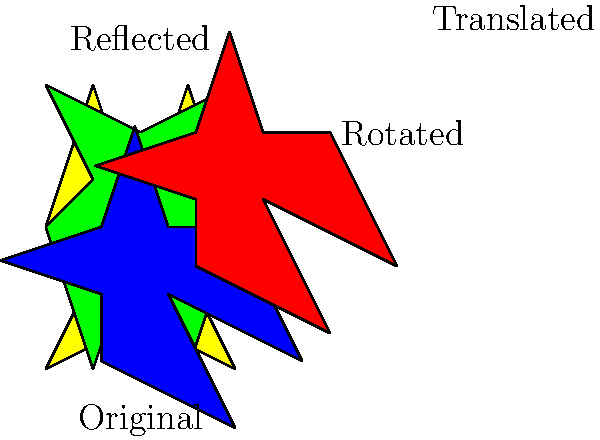In the diagram above, a star shape representing Madeline Brewer's career undergoes multiple transformations. If the original yellow star represents her early roles, identify the sequence of transformations that leads to the final red star, symbolizing her rise to stardom in "The Handmaid's Tale." To transform the original yellow star into the final red star, we need to follow these steps:

1. Reflection: The green star is obtained by reflecting the original yellow star across the x-axis. This can be represented mathematically as $(x, y) \rightarrow (x, -y)$.

2. Rotation: The blue star is created by rotating the green star 45° clockwise around the point (4,0). The rotation matrix for this transformation is:

   $$\begin{bmatrix} 
   \cos 45° & \sin 45° \\
   -\sin 45° & \cos 45°
   \end{bmatrix}$$

3. Translation: Finally, the red star is obtained by translating the blue star 2 units to the right and 2 units up. This can be represented as $(x, y) \rightarrow (x+2, y+2)$.

Therefore, the complete sequence of transformations is: reflection across the x-axis, followed by a 45° clockwise rotation around (4,0), and then a translation of (2,2).
Answer: Reflection, 45° rotation, translation (2,2) 